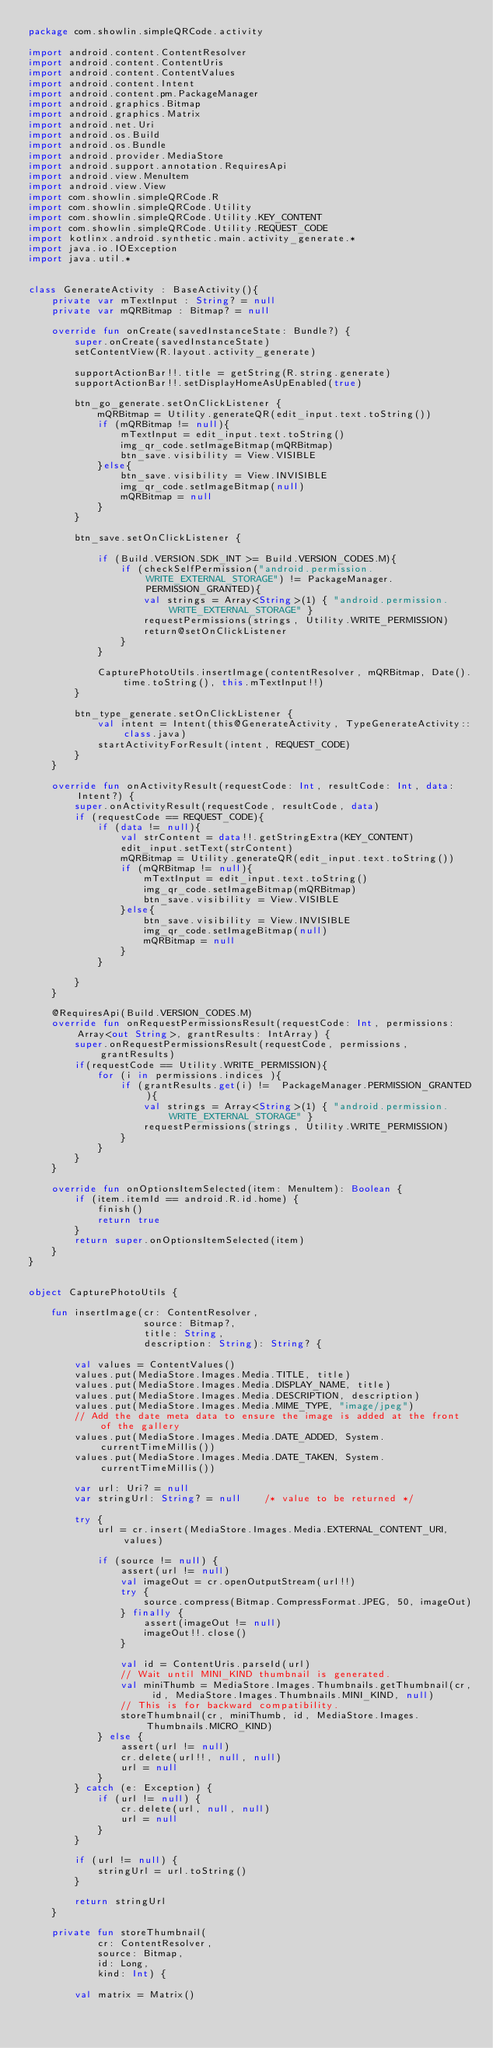<code> <loc_0><loc_0><loc_500><loc_500><_Kotlin_>package com.showlin.simpleQRCode.activity

import android.content.ContentResolver
import android.content.ContentUris
import android.content.ContentValues
import android.content.Intent
import android.content.pm.PackageManager
import android.graphics.Bitmap
import android.graphics.Matrix
import android.net.Uri
import android.os.Build
import android.os.Bundle
import android.provider.MediaStore
import android.support.annotation.RequiresApi
import android.view.MenuItem
import android.view.View
import com.showlin.simpleQRCode.R
import com.showlin.simpleQRCode.Utility
import com.showlin.simpleQRCode.Utility.KEY_CONTENT
import com.showlin.simpleQRCode.Utility.REQUEST_CODE
import kotlinx.android.synthetic.main.activity_generate.*
import java.io.IOException
import java.util.*


class GenerateActivity : BaseActivity(){
    private var mTextInput : String? = null
    private var mQRBitmap : Bitmap? = null

    override fun onCreate(savedInstanceState: Bundle?) {
        super.onCreate(savedInstanceState)
        setContentView(R.layout.activity_generate)

        supportActionBar!!.title = getString(R.string.generate)
        supportActionBar!!.setDisplayHomeAsUpEnabled(true)

        btn_go_generate.setOnClickListener {
            mQRBitmap = Utility.generateQR(edit_input.text.toString())
            if (mQRBitmap != null){
                mTextInput = edit_input.text.toString()
                img_qr_code.setImageBitmap(mQRBitmap)
                btn_save.visibility = View.VISIBLE
            }else{
                btn_save.visibility = View.INVISIBLE
                img_qr_code.setImageBitmap(null)
                mQRBitmap = null
            }
        }

        btn_save.setOnClickListener {

            if (Build.VERSION.SDK_INT >= Build.VERSION_CODES.M){
                if (checkSelfPermission("android.permission.WRITE_EXTERNAL_STORAGE") != PackageManager.PERMISSION_GRANTED){
                    val strings = Array<String>(1) { "android.permission.WRITE_EXTERNAL_STORAGE" }
                    requestPermissions(strings, Utility.WRITE_PERMISSION)
                    return@setOnClickListener
                }
            }

            CapturePhotoUtils.insertImage(contentResolver, mQRBitmap, Date().time.toString(), this.mTextInput!!)
        }

        btn_type_generate.setOnClickListener {
            val intent = Intent(this@GenerateActivity, TypeGenerateActivity::class.java)
            startActivityForResult(intent, REQUEST_CODE)
        }
    }

    override fun onActivityResult(requestCode: Int, resultCode: Int, data: Intent?) {
        super.onActivityResult(requestCode, resultCode, data)
        if (requestCode == REQUEST_CODE){
            if (data != null){
                val strContent = data!!.getStringExtra(KEY_CONTENT)
                edit_input.setText(strContent)
                mQRBitmap = Utility.generateQR(edit_input.text.toString())
                if (mQRBitmap != null){
                    mTextInput = edit_input.text.toString()
                    img_qr_code.setImageBitmap(mQRBitmap)
                    btn_save.visibility = View.VISIBLE
                }else{
                    btn_save.visibility = View.INVISIBLE
                    img_qr_code.setImageBitmap(null)
                    mQRBitmap = null
                }
            }

        }
    }

    @RequiresApi(Build.VERSION_CODES.M)
    override fun onRequestPermissionsResult(requestCode: Int, permissions: Array<out String>, grantResults: IntArray) {
        super.onRequestPermissionsResult(requestCode, permissions, grantResults)
        if(requestCode == Utility.WRITE_PERMISSION){
            for (i in permissions.indices ){
                if (grantResults.get(i) !=  PackageManager.PERMISSION_GRANTED){
                    val strings = Array<String>(1) { "android.permission.WRITE_EXTERNAL_STORAGE" }
                    requestPermissions(strings, Utility.WRITE_PERMISSION)
                }
            }
        }
    }

    override fun onOptionsItemSelected(item: MenuItem): Boolean {
        if (item.itemId == android.R.id.home) {
            finish()
            return true
        }
        return super.onOptionsItemSelected(item)
    }
}


object CapturePhotoUtils {

    fun insertImage(cr: ContentResolver,
                    source: Bitmap?,
                    title: String,
                    description: String): String? {

        val values = ContentValues()
        values.put(MediaStore.Images.Media.TITLE, title)
        values.put(MediaStore.Images.Media.DISPLAY_NAME, title)
        values.put(MediaStore.Images.Media.DESCRIPTION, description)
        values.put(MediaStore.Images.Media.MIME_TYPE, "image/jpeg")
        // Add the date meta data to ensure the image is added at the front of the gallery
        values.put(MediaStore.Images.Media.DATE_ADDED, System.currentTimeMillis())
        values.put(MediaStore.Images.Media.DATE_TAKEN, System.currentTimeMillis())

        var url: Uri? = null
        var stringUrl: String? = null    /* value to be returned */

        try {
            url = cr.insert(MediaStore.Images.Media.EXTERNAL_CONTENT_URI, values)

            if (source != null) {
                assert(url != null)
                val imageOut = cr.openOutputStream(url!!)
                try {
                    source.compress(Bitmap.CompressFormat.JPEG, 50, imageOut)
                } finally {
                    assert(imageOut != null)
                    imageOut!!.close()
                }

                val id = ContentUris.parseId(url)
                // Wait until MINI_KIND thumbnail is generated.
                val miniThumb = MediaStore.Images.Thumbnails.getThumbnail(cr, id, MediaStore.Images.Thumbnails.MINI_KIND, null)
                // This is for backward compatibility.
                storeThumbnail(cr, miniThumb, id, MediaStore.Images.Thumbnails.MICRO_KIND)
            } else {
                assert(url != null)
                cr.delete(url!!, null, null)
                url = null
            }
        } catch (e: Exception) {
            if (url != null) {
                cr.delete(url, null, null)
                url = null
            }
        }

        if (url != null) {
            stringUrl = url.toString()
        }

        return stringUrl
    }

    private fun storeThumbnail(
            cr: ContentResolver,
            source: Bitmap,
            id: Long,
            kind: Int) {

        val matrix = Matrix()
</code> 